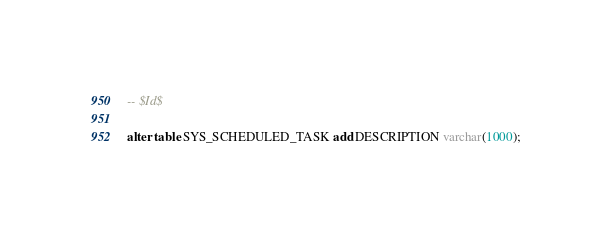Convert code to text. <code><loc_0><loc_0><loc_500><loc_500><_SQL_>-- $Id$

alter table SYS_SCHEDULED_TASK add DESCRIPTION varchar(1000);</code> 